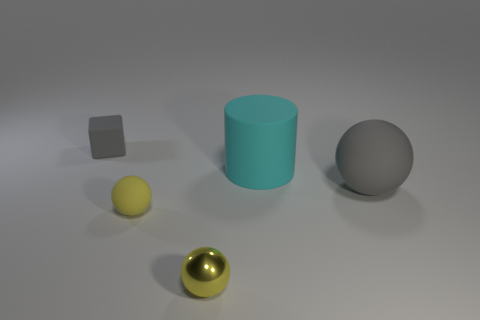There is a rubber object that is the same color as the big rubber ball; what size is it?
Give a very brief answer. Small. There is a object that is both behind the large matte sphere and on the right side of the small gray cube; how big is it?
Make the answer very short. Large. There is a large rubber ball; does it have the same color as the rubber object behind the cyan thing?
Provide a short and direct response. Yes. What is the color of the tiny matte object in front of the tiny object behind the gray object right of the small gray matte thing?
Your answer should be very brief. Yellow. Is there another cube of the same size as the rubber block?
Make the answer very short. No. There is a yellow ball that is the same size as the yellow matte thing; what is it made of?
Make the answer very short. Metal. Is there a large gray matte object that has the same shape as the yellow shiny object?
Your answer should be compact. Yes. What is the material of the ball that is the same color as the small cube?
Offer a very short reply. Rubber. There is a small rubber thing that is behind the big sphere; what shape is it?
Provide a succinct answer. Cube. What number of rubber blocks are there?
Keep it short and to the point. 1. 